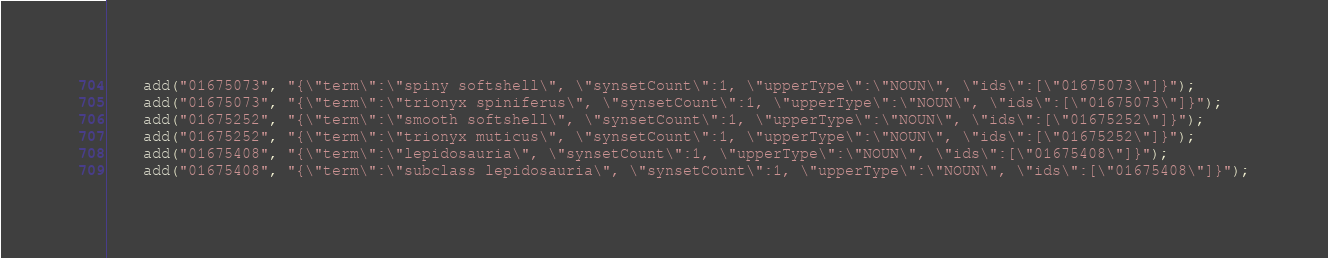Convert code to text. <code><loc_0><loc_0><loc_500><loc_500><_Java_>	add("01675073", "{\"term\":\"spiny softshell\", \"synsetCount\":1, \"upperType\":\"NOUN\", \"ids\":[\"01675073\"]}");
	add("01675073", "{\"term\":\"trionyx spiniferus\", \"synsetCount\":1, \"upperType\":\"NOUN\", \"ids\":[\"01675073\"]}");
	add("01675252", "{\"term\":\"smooth softshell\", \"synsetCount\":1, \"upperType\":\"NOUN\", \"ids\":[\"01675252\"]}");
	add("01675252", "{\"term\":\"trionyx muticus\", \"synsetCount\":1, \"upperType\":\"NOUN\", \"ids\":[\"01675252\"]}");
	add("01675408", "{\"term\":\"lepidosauria\", \"synsetCount\":1, \"upperType\":\"NOUN\", \"ids\":[\"01675408\"]}");
	add("01675408", "{\"term\":\"subclass lepidosauria\", \"synsetCount\":1, \"upperType\":\"NOUN\", \"ids\":[\"01675408\"]}");</code> 